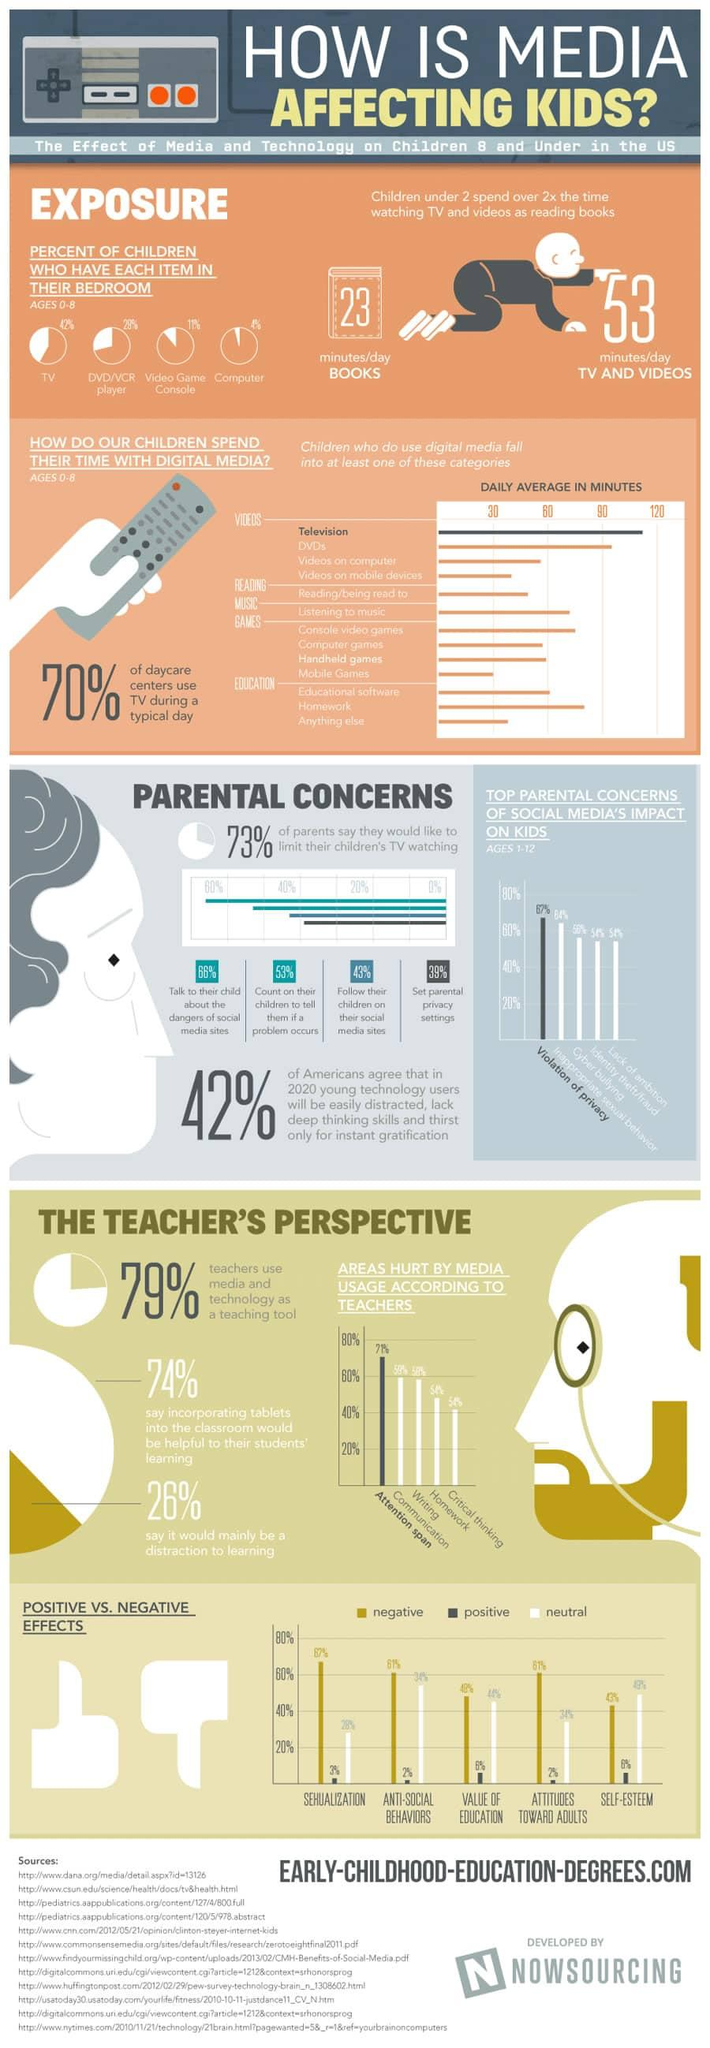List a handful of essential elements in this visual. According to a recent survey, only 43% of parents follow their children on their social media sites. According to 58%-60% of teachers, the two main areas negatively impacted by media usage are communication and writing. The color of the dress of the toddler is blue. A significant percentage of parents are concerned about social media's impact on children, particularly regarding issues of privacy violation and inappropriate sexual behavior. According to statistics, children under the age of 2 spend significantly more time watching TV and videos than they do reading books. 